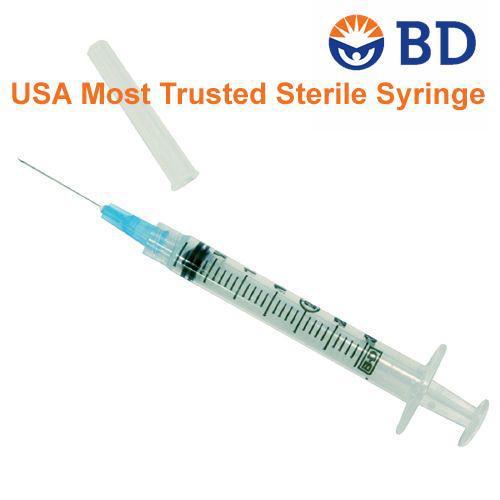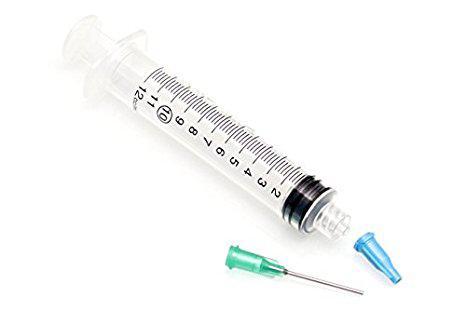The first image is the image on the left, the second image is the image on the right. Examine the images to the left and right. Is the description "In the image to the right, the needle is NOT connected to the syringe; the syringe cannot presently enter the skin." accurate? Answer yes or no. Yes. The first image is the image on the left, the second image is the image on the right. Examine the images to the left and right. Is the description "There are exactly two syringes." accurate? Answer yes or no. Yes. 